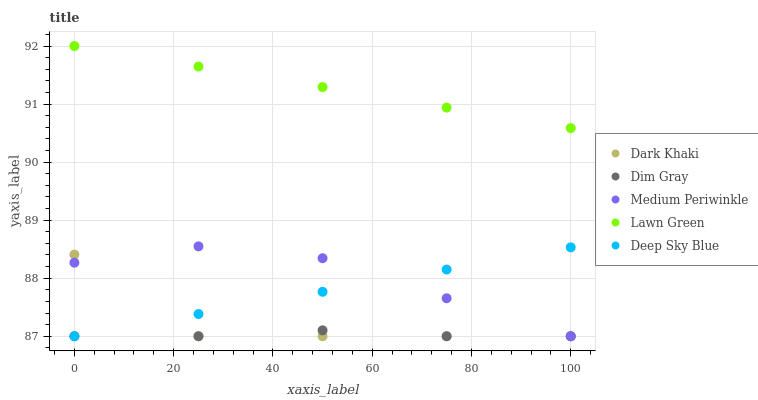Does Dim Gray have the minimum area under the curve?
Answer yes or no. Yes. Does Lawn Green have the maximum area under the curve?
Answer yes or no. Yes. Does Lawn Green have the minimum area under the curve?
Answer yes or no. No. Does Dim Gray have the maximum area under the curve?
Answer yes or no. No. Is Deep Sky Blue the smoothest?
Answer yes or no. Yes. Is Dark Khaki the roughest?
Answer yes or no. Yes. Is Lawn Green the smoothest?
Answer yes or no. No. Is Lawn Green the roughest?
Answer yes or no. No. Does Dark Khaki have the lowest value?
Answer yes or no. Yes. Does Lawn Green have the lowest value?
Answer yes or no. No. Does Lawn Green have the highest value?
Answer yes or no. Yes. Does Dim Gray have the highest value?
Answer yes or no. No. Is Medium Periwinkle less than Lawn Green?
Answer yes or no. Yes. Is Lawn Green greater than Dim Gray?
Answer yes or no. Yes. Does Dark Khaki intersect Dim Gray?
Answer yes or no. Yes. Is Dark Khaki less than Dim Gray?
Answer yes or no. No. Is Dark Khaki greater than Dim Gray?
Answer yes or no. No. Does Medium Periwinkle intersect Lawn Green?
Answer yes or no. No. 